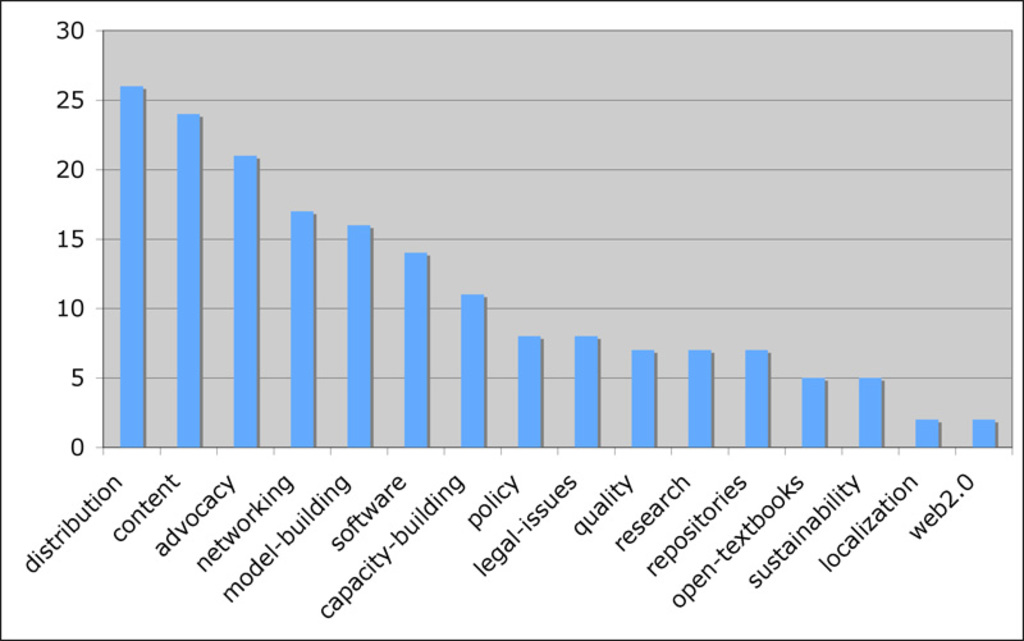What issue is of the largest concern, and which is the least, according to the chart?  How significant are legal issues compared to policy ones? The issue of greatest concern according to the chart is "distribution," as it has the highest bar, reaching close to 30 on the vertical axis. The issue of least concern appears to be "web 2.0," with its bar being the shortest, indicating a value just above 0 on the vertical axis.

Legal issues are of relatively moderate concern compared with policy issues. The bar for legal issues is around the midpoint of the chart, with a value between 10 and 15, while the bar for policy issues is slightly shorter, with a value that appears to be around 10. Therefore, legal issues are shown to be of slightly higher concern than policy issues based on this chart. 